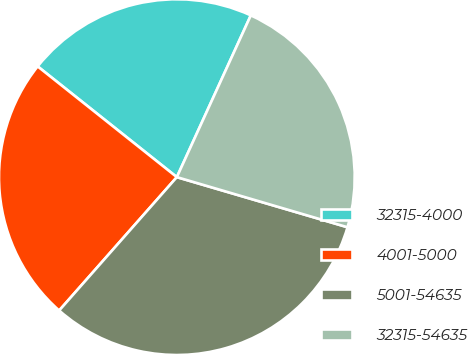Convert chart to OTSL. <chart><loc_0><loc_0><loc_500><loc_500><pie_chart><fcel>32315-4000<fcel>4001-5000<fcel>5001-54635<fcel>32315-54635<nl><fcel>21.13%<fcel>24.19%<fcel>31.96%<fcel>22.72%<nl></chart> 